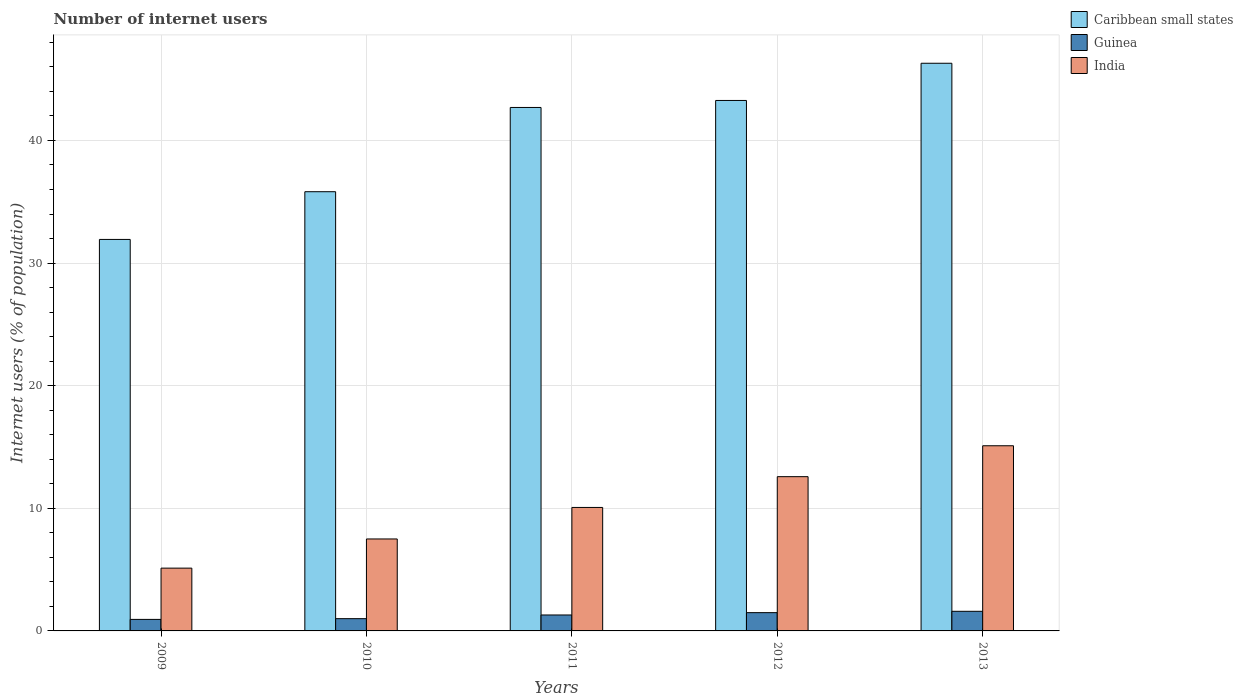How many groups of bars are there?
Give a very brief answer. 5. Are the number of bars on each tick of the X-axis equal?
Provide a succinct answer. Yes. In how many cases, is the number of bars for a given year not equal to the number of legend labels?
Make the answer very short. 0. What is the number of internet users in India in 2012?
Keep it short and to the point. 12.58. Across all years, what is the maximum number of internet users in Caribbean small states?
Offer a terse response. 46.29. In which year was the number of internet users in Guinea maximum?
Provide a short and direct response. 2013. In which year was the number of internet users in Guinea minimum?
Provide a succinct answer. 2009. What is the total number of internet users in Guinea in the graph?
Give a very brief answer. 6.33. What is the difference between the number of internet users in India in 2009 and that in 2013?
Your answer should be very brief. -9.98. What is the difference between the number of internet users in Guinea in 2011 and the number of internet users in Caribbean small states in 2010?
Your answer should be very brief. -34.52. What is the average number of internet users in Guinea per year?
Make the answer very short. 1.27. In the year 2012, what is the difference between the number of internet users in Guinea and number of internet users in Caribbean small states?
Give a very brief answer. -41.77. What is the ratio of the number of internet users in India in 2009 to that in 2013?
Your answer should be compact. 0.34. What is the difference between the highest and the second highest number of internet users in India?
Offer a terse response. 2.52. What is the difference between the highest and the lowest number of internet users in Guinea?
Your answer should be very brief. 0.66. Is the sum of the number of internet users in Guinea in 2009 and 2013 greater than the maximum number of internet users in Caribbean small states across all years?
Make the answer very short. No. What does the 1st bar from the left in 2011 represents?
Provide a succinct answer. Caribbean small states. Is it the case that in every year, the sum of the number of internet users in India and number of internet users in Caribbean small states is greater than the number of internet users in Guinea?
Give a very brief answer. Yes. What is the difference between two consecutive major ticks on the Y-axis?
Offer a terse response. 10. Are the values on the major ticks of Y-axis written in scientific E-notation?
Keep it short and to the point. No. Does the graph contain any zero values?
Give a very brief answer. No. Where does the legend appear in the graph?
Your response must be concise. Top right. How many legend labels are there?
Your answer should be very brief. 3. What is the title of the graph?
Provide a succinct answer. Number of internet users. Does "Fiji" appear as one of the legend labels in the graph?
Provide a short and direct response. No. What is the label or title of the Y-axis?
Ensure brevity in your answer.  Internet users (% of population). What is the Internet users (% of population) of Caribbean small states in 2009?
Provide a short and direct response. 31.93. What is the Internet users (% of population) in India in 2009?
Provide a succinct answer. 5.12. What is the Internet users (% of population) in Caribbean small states in 2010?
Offer a terse response. 35.82. What is the Internet users (% of population) in Guinea in 2010?
Give a very brief answer. 1. What is the Internet users (% of population) of Caribbean small states in 2011?
Provide a short and direct response. 42.69. What is the Internet users (% of population) in Guinea in 2011?
Offer a very short reply. 1.3. What is the Internet users (% of population) in India in 2011?
Your answer should be very brief. 10.07. What is the Internet users (% of population) in Caribbean small states in 2012?
Your answer should be very brief. 43.26. What is the Internet users (% of population) in Guinea in 2012?
Your answer should be very brief. 1.49. What is the Internet users (% of population) of India in 2012?
Provide a short and direct response. 12.58. What is the Internet users (% of population) of Caribbean small states in 2013?
Give a very brief answer. 46.29. What is the Internet users (% of population) in Guinea in 2013?
Give a very brief answer. 1.6. What is the Internet users (% of population) of India in 2013?
Provide a short and direct response. 15.1. Across all years, what is the maximum Internet users (% of population) in Caribbean small states?
Give a very brief answer. 46.29. Across all years, what is the maximum Internet users (% of population) of India?
Keep it short and to the point. 15.1. Across all years, what is the minimum Internet users (% of population) in Caribbean small states?
Provide a short and direct response. 31.93. Across all years, what is the minimum Internet users (% of population) in India?
Provide a short and direct response. 5.12. What is the total Internet users (% of population) in Caribbean small states in the graph?
Ensure brevity in your answer.  199.99. What is the total Internet users (% of population) in Guinea in the graph?
Provide a succinct answer. 6.33. What is the total Internet users (% of population) of India in the graph?
Offer a terse response. 50.37. What is the difference between the Internet users (% of population) of Caribbean small states in 2009 and that in 2010?
Provide a succinct answer. -3.89. What is the difference between the Internet users (% of population) in Guinea in 2009 and that in 2010?
Provide a succinct answer. -0.06. What is the difference between the Internet users (% of population) of India in 2009 and that in 2010?
Make the answer very short. -2.38. What is the difference between the Internet users (% of population) in Caribbean small states in 2009 and that in 2011?
Your response must be concise. -10.76. What is the difference between the Internet users (% of population) in Guinea in 2009 and that in 2011?
Give a very brief answer. -0.36. What is the difference between the Internet users (% of population) of India in 2009 and that in 2011?
Your answer should be compact. -4.95. What is the difference between the Internet users (% of population) in Caribbean small states in 2009 and that in 2012?
Give a very brief answer. -11.33. What is the difference between the Internet users (% of population) of Guinea in 2009 and that in 2012?
Your response must be concise. -0.55. What is the difference between the Internet users (% of population) of India in 2009 and that in 2012?
Give a very brief answer. -7.46. What is the difference between the Internet users (% of population) of Caribbean small states in 2009 and that in 2013?
Your response must be concise. -14.37. What is the difference between the Internet users (% of population) of Guinea in 2009 and that in 2013?
Provide a succinct answer. -0.66. What is the difference between the Internet users (% of population) of India in 2009 and that in 2013?
Your answer should be compact. -9.98. What is the difference between the Internet users (% of population) of Caribbean small states in 2010 and that in 2011?
Your answer should be compact. -6.87. What is the difference between the Internet users (% of population) of India in 2010 and that in 2011?
Give a very brief answer. -2.57. What is the difference between the Internet users (% of population) of Caribbean small states in 2010 and that in 2012?
Provide a short and direct response. -7.44. What is the difference between the Internet users (% of population) in Guinea in 2010 and that in 2012?
Provide a short and direct response. -0.49. What is the difference between the Internet users (% of population) in India in 2010 and that in 2012?
Provide a succinct answer. -5.08. What is the difference between the Internet users (% of population) in Caribbean small states in 2010 and that in 2013?
Keep it short and to the point. -10.48. What is the difference between the Internet users (% of population) of Caribbean small states in 2011 and that in 2012?
Offer a terse response. -0.57. What is the difference between the Internet users (% of population) of Guinea in 2011 and that in 2012?
Provide a succinct answer. -0.19. What is the difference between the Internet users (% of population) of India in 2011 and that in 2012?
Keep it short and to the point. -2.51. What is the difference between the Internet users (% of population) in Caribbean small states in 2011 and that in 2013?
Give a very brief answer. -3.61. What is the difference between the Internet users (% of population) of Guinea in 2011 and that in 2013?
Provide a short and direct response. -0.3. What is the difference between the Internet users (% of population) of India in 2011 and that in 2013?
Your answer should be very brief. -5.03. What is the difference between the Internet users (% of population) in Caribbean small states in 2012 and that in 2013?
Make the answer very short. -3.03. What is the difference between the Internet users (% of population) of Guinea in 2012 and that in 2013?
Your answer should be compact. -0.11. What is the difference between the Internet users (% of population) of India in 2012 and that in 2013?
Offer a very short reply. -2.52. What is the difference between the Internet users (% of population) in Caribbean small states in 2009 and the Internet users (% of population) in Guinea in 2010?
Give a very brief answer. 30.93. What is the difference between the Internet users (% of population) in Caribbean small states in 2009 and the Internet users (% of population) in India in 2010?
Give a very brief answer. 24.43. What is the difference between the Internet users (% of population) of Guinea in 2009 and the Internet users (% of population) of India in 2010?
Give a very brief answer. -6.56. What is the difference between the Internet users (% of population) in Caribbean small states in 2009 and the Internet users (% of population) in Guinea in 2011?
Ensure brevity in your answer.  30.63. What is the difference between the Internet users (% of population) of Caribbean small states in 2009 and the Internet users (% of population) of India in 2011?
Give a very brief answer. 21.86. What is the difference between the Internet users (% of population) in Guinea in 2009 and the Internet users (% of population) in India in 2011?
Your answer should be very brief. -9.13. What is the difference between the Internet users (% of population) of Caribbean small states in 2009 and the Internet users (% of population) of Guinea in 2012?
Provide a short and direct response. 30.44. What is the difference between the Internet users (% of population) in Caribbean small states in 2009 and the Internet users (% of population) in India in 2012?
Your response must be concise. 19.35. What is the difference between the Internet users (% of population) in Guinea in 2009 and the Internet users (% of population) in India in 2012?
Provide a succinct answer. -11.64. What is the difference between the Internet users (% of population) of Caribbean small states in 2009 and the Internet users (% of population) of Guinea in 2013?
Your answer should be compact. 30.33. What is the difference between the Internet users (% of population) of Caribbean small states in 2009 and the Internet users (% of population) of India in 2013?
Keep it short and to the point. 16.83. What is the difference between the Internet users (% of population) of Guinea in 2009 and the Internet users (% of population) of India in 2013?
Give a very brief answer. -14.16. What is the difference between the Internet users (% of population) in Caribbean small states in 2010 and the Internet users (% of population) in Guinea in 2011?
Give a very brief answer. 34.52. What is the difference between the Internet users (% of population) in Caribbean small states in 2010 and the Internet users (% of population) in India in 2011?
Your answer should be very brief. 25.75. What is the difference between the Internet users (% of population) in Guinea in 2010 and the Internet users (% of population) in India in 2011?
Keep it short and to the point. -9.07. What is the difference between the Internet users (% of population) in Caribbean small states in 2010 and the Internet users (% of population) in Guinea in 2012?
Provide a succinct answer. 34.33. What is the difference between the Internet users (% of population) in Caribbean small states in 2010 and the Internet users (% of population) in India in 2012?
Provide a succinct answer. 23.24. What is the difference between the Internet users (% of population) in Guinea in 2010 and the Internet users (% of population) in India in 2012?
Your answer should be compact. -11.58. What is the difference between the Internet users (% of population) in Caribbean small states in 2010 and the Internet users (% of population) in Guinea in 2013?
Keep it short and to the point. 34.22. What is the difference between the Internet users (% of population) of Caribbean small states in 2010 and the Internet users (% of population) of India in 2013?
Make the answer very short. 20.72. What is the difference between the Internet users (% of population) of Guinea in 2010 and the Internet users (% of population) of India in 2013?
Give a very brief answer. -14.1. What is the difference between the Internet users (% of population) of Caribbean small states in 2011 and the Internet users (% of population) of Guinea in 2012?
Make the answer very short. 41.2. What is the difference between the Internet users (% of population) in Caribbean small states in 2011 and the Internet users (% of population) in India in 2012?
Offer a very short reply. 30.11. What is the difference between the Internet users (% of population) in Guinea in 2011 and the Internet users (% of population) in India in 2012?
Make the answer very short. -11.28. What is the difference between the Internet users (% of population) in Caribbean small states in 2011 and the Internet users (% of population) in Guinea in 2013?
Keep it short and to the point. 41.09. What is the difference between the Internet users (% of population) of Caribbean small states in 2011 and the Internet users (% of population) of India in 2013?
Make the answer very short. 27.59. What is the difference between the Internet users (% of population) in Guinea in 2011 and the Internet users (% of population) in India in 2013?
Offer a terse response. -13.8. What is the difference between the Internet users (% of population) of Caribbean small states in 2012 and the Internet users (% of population) of Guinea in 2013?
Your answer should be compact. 41.66. What is the difference between the Internet users (% of population) in Caribbean small states in 2012 and the Internet users (% of population) in India in 2013?
Provide a short and direct response. 28.16. What is the difference between the Internet users (% of population) of Guinea in 2012 and the Internet users (% of population) of India in 2013?
Ensure brevity in your answer.  -13.61. What is the average Internet users (% of population) in Caribbean small states per year?
Your answer should be compact. 40. What is the average Internet users (% of population) of Guinea per year?
Ensure brevity in your answer.  1.27. What is the average Internet users (% of population) in India per year?
Your answer should be very brief. 10.07. In the year 2009, what is the difference between the Internet users (% of population) in Caribbean small states and Internet users (% of population) in Guinea?
Ensure brevity in your answer.  30.99. In the year 2009, what is the difference between the Internet users (% of population) in Caribbean small states and Internet users (% of population) in India?
Provide a succinct answer. 26.81. In the year 2009, what is the difference between the Internet users (% of population) of Guinea and Internet users (% of population) of India?
Give a very brief answer. -4.18. In the year 2010, what is the difference between the Internet users (% of population) of Caribbean small states and Internet users (% of population) of Guinea?
Make the answer very short. 34.82. In the year 2010, what is the difference between the Internet users (% of population) of Caribbean small states and Internet users (% of population) of India?
Make the answer very short. 28.32. In the year 2011, what is the difference between the Internet users (% of population) in Caribbean small states and Internet users (% of population) in Guinea?
Make the answer very short. 41.39. In the year 2011, what is the difference between the Internet users (% of population) of Caribbean small states and Internet users (% of population) of India?
Provide a succinct answer. 32.62. In the year 2011, what is the difference between the Internet users (% of population) in Guinea and Internet users (% of population) in India?
Your answer should be compact. -8.77. In the year 2012, what is the difference between the Internet users (% of population) in Caribbean small states and Internet users (% of population) in Guinea?
Your answer should be compact. 41.77. In the year 2012, what is the difference between the Internet users (% of population) of Caribbean small states and Internet users (% of population) of India?
Your response must be concise. 30.68. In the year 2012, what is the difference between the Internet users (% of population) of Guinea and Internet users (% of population) of India?
Your response must be concise. -11.09. In the year 2013, what is the difference between the Internet users (% of population) of Caribbean small states and Internet users (% of population) of Guinea?
Your answer should be compact. 44.69. In the year 2013, what is the difference between the Internet users (% of population) in Caribbean small states and Internet users (% of population) in India?
Provide a succinct answer. 31.19. What is the ratio of the Internet users (% of population) of Caribbean small states in 2009 to that in 2010?
Make the answer very short. 0.89. What is the ratio of the Internet users (% of population) of Guinea in 2009 to that in 2010?
Offer a terse response. 0.94. What is the ratio of the Internet users (% of population) in India in 2009 to that in 2010?
Give a very brief answer. 0.68. What is the ratio of the Internet users (% of population) in Caribbean small states in 2009 to that in 2011?
Offer a very short reply. 0.75. What is the ratio of the Internet users (% of population) of Guinea in 2009 to that in 2011?
Your answer should be very brief. 0.72. What is the ratio of the Internet users (% of population) in India in 2009 to that in 2011?
Offer a very short reply. 0.51. What is the ratio of the Internet users (% of population) in Caribbean small states in 2009 to that in 2012?
Make the answer very short. 0.74. What is the ratio of the Internet users (% of population) of Guinea in 2009 to that in 2012?
Provide a short and direct response. 0.63. What is the ratio of the Internet users (% of population) in India in 2009 to that in 2012?
Ensure brevity in your answer.  0.41. What is the ratio of the Internet users (% of population) of Caribbean small states in 2009 to that in 2013?
Provide a succinct answer. 0.69. What is the ratio of the Internet users (% of population) in Guinea in 2009 to that in 2013?
Make the answer very short. 0.59. What is the ratio of the Internet users (% of population) in India in 2009 to that in 2013?
Your answer should be compact. 0.34. What is the ratio of the Internet users (% of population) of Caribbean small states in 2010 to that in 2011?
Give a very brief answer. 0.84. What is the ratio of the Internet users (% of population) of Guinea in 2010 to that in 2011?
Ensure brevity in your answer.  0.77. What is the ratio of the Internet users (% of population) of India in 2010 to that in 2011?
Keep it short and to the point. 0.74. What is the ratio of the Internet users (% of population) of Caribbean small states in 2010 to that in 2012?
Offer a very short reply. 0.83. What is the ratio of the Internet users (% of population) of Guinea in 2010 to that in 2012?
Your answer should be very brief. 0.67. What is the ratio of the Internet users (% of population) of India in 2010 to that in 2012?
Your response must be concise. 0.6. What is the ratio of the Internet users (% of population) of Caribbean small states in 2010 to that in 2013?
Your response must be concise. 0.77. What is the ratio of the Internet users (% of population) of Guinea in 2010 to that in 2013?
Give a very brief answer. 0.62. What is the ratio of the Internet users (% of population) in India in 2010 to that in 2013?
Your response must be concise. 0.5. What is the ratio of the Internet users (% of population) in Guinea in 2011 to that in 2012?
Offer a very short reply. 0.87. What is the ratio of the Internet users (% of population) in India in 2011 to that in 2012?
Provide a short and direct response. 0.8. What is the ratio of the Internet users (% of population) in Caribbean small states in 2011 to that in 2013?
Give a very brief answer. 0.92. What is the ratio of the Internet users (% of population) in Guinea in 2011 to that in 2013?
Provide a succinct answer. 0.81. What is the ratio of the Internet users (% of population) of India in 2011 to that in 2013?
Keep it short and to the point. 0.67. What is the ratio of the Internet users (% of population) in Caribbean small states in 2012 to that in 2013?
Offer a very short reply. 0.93. What is the ratio of the Internet users (% of population) of Guinea in 2012 to that in 2013?
Keep it short and to the point. 0.93. What is the ratio of the Internet users (% of population) of India in 2012 to that in 2013?
Your response must be concise. 0.83. What is the difference between the highest and the second highest Internet users (% of population) of Caribbean small states?
Make the answer very short. 3.03. What is the difference between the highest and the second highest Internet users (% of population) in Guinea?
Provide a succinct answer. 0.11. What is the difference between the highest and the second highest Internet users (% of population) in India?
Ensure brevity in your answer.  2.52. What is the difference between the highest and the lowest Internet users (% of population) of Caribbean small states?
Make the answer very short. 14.37. What is the difference between the highest and the lowest Internet users (% of population) of Guinea?
Make the answer very short. 0.66. What is the difference between the highest and the lowest Internet users (% of population) of India?
Provide a short and direct response. 9.98. 